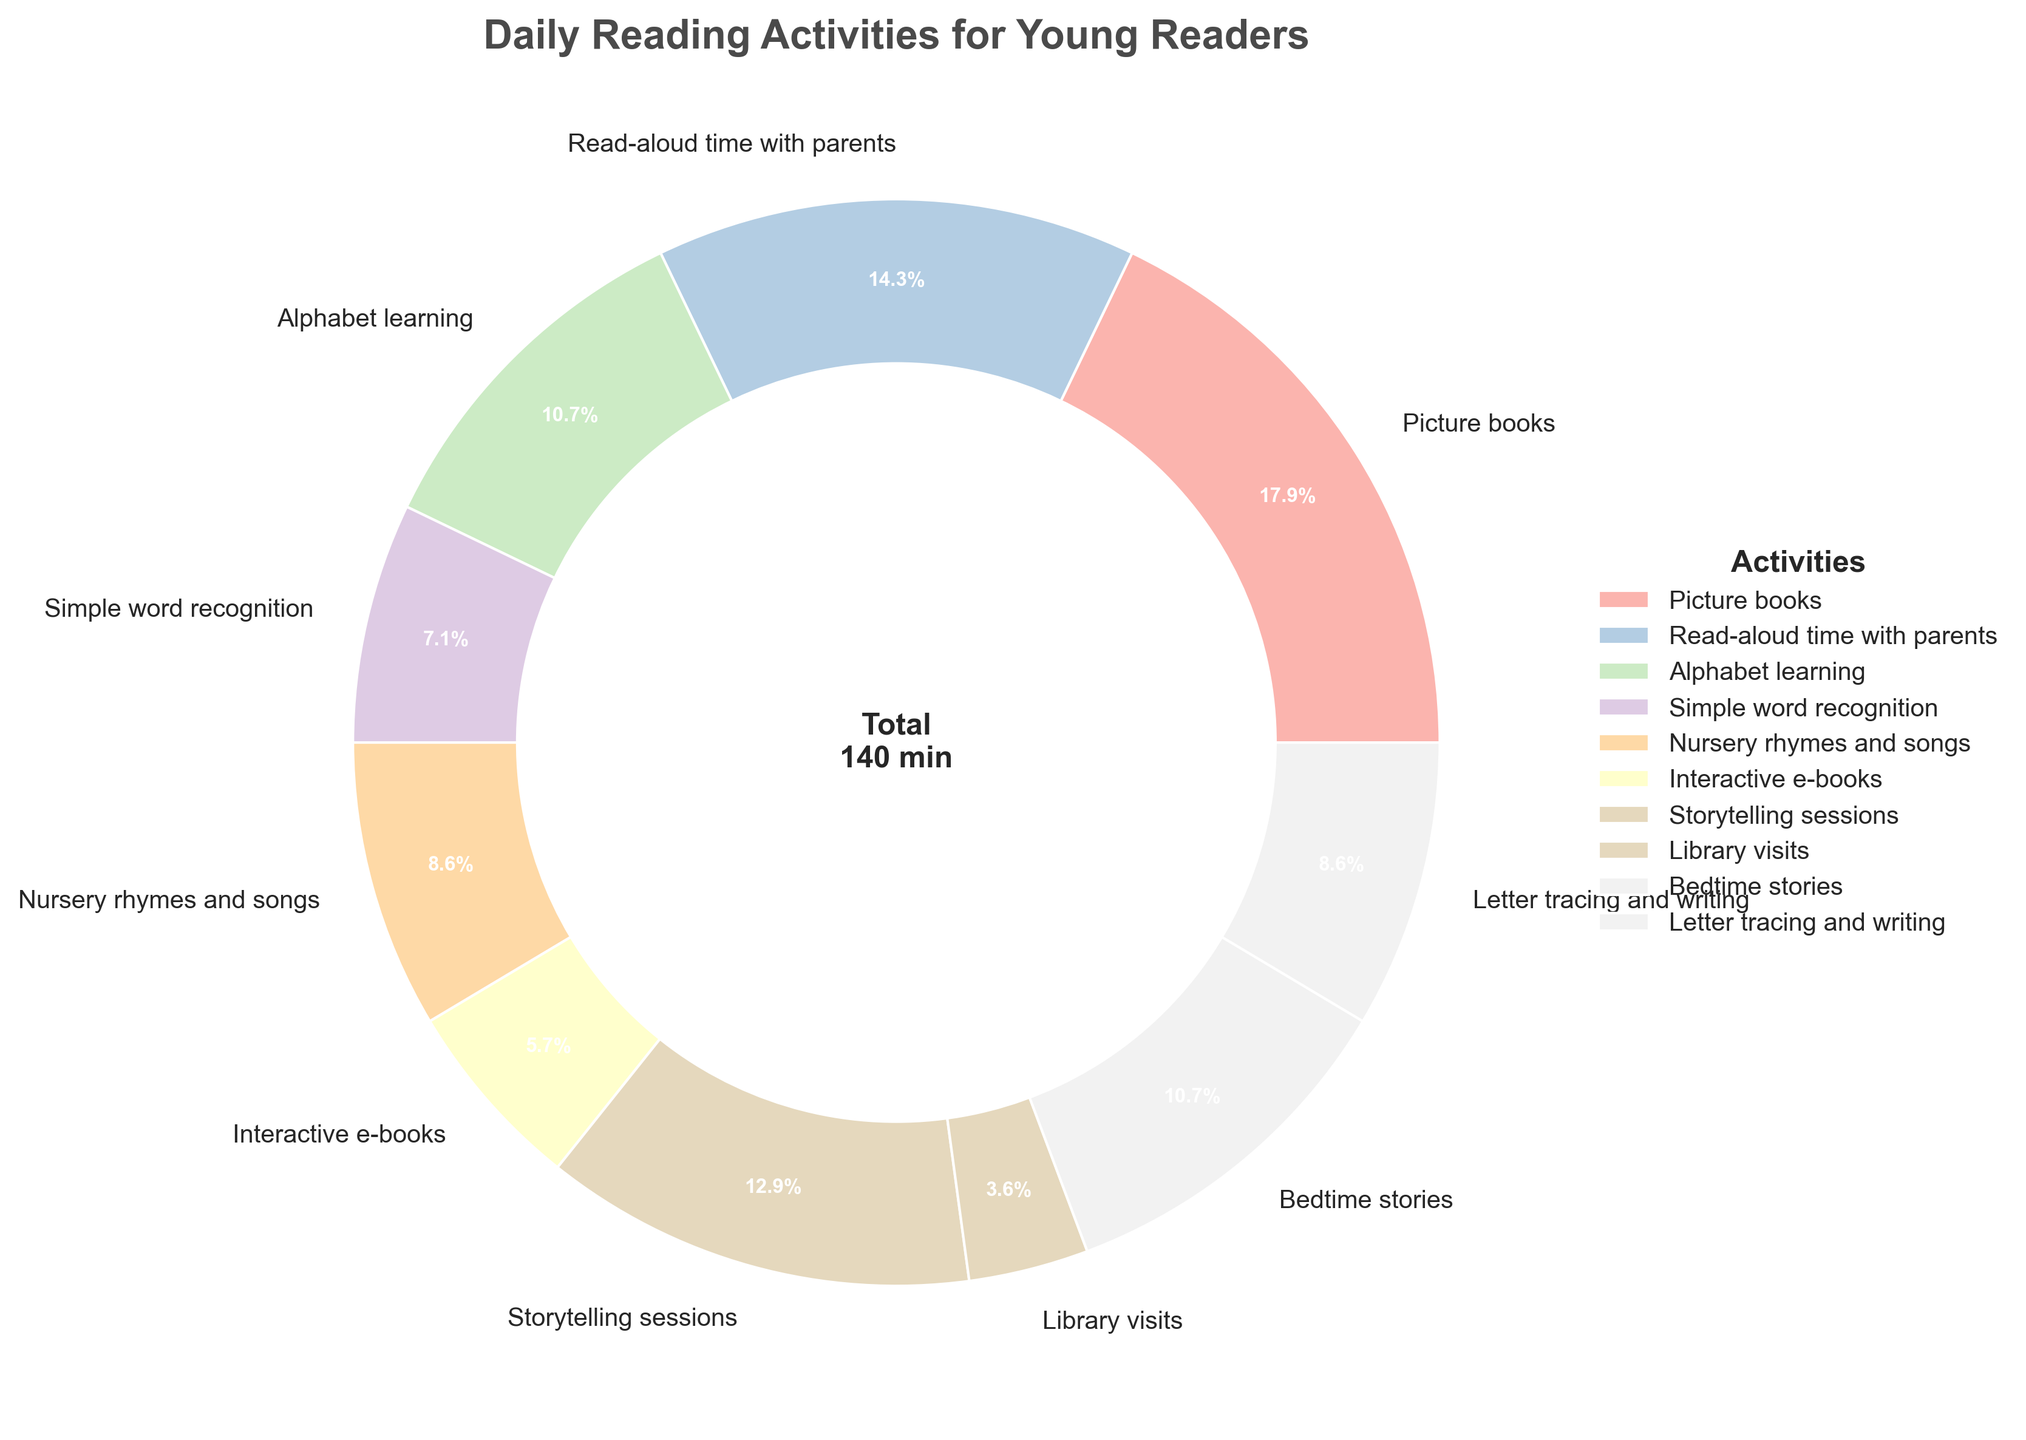What activity is spent the most time on? The activity with the largest slice on the pie chart (which is the visually largest portion) would be the one spent the most time on. Looking at the chart, the largest portion belongs to "Picture books."
Answer: Picture books How many minutes are spent on activities related to learning letters (Alphabet learning and Letter tracing and writing)? Add the minutes spent on "Alphabet learning" and "Letter tracing and writing." From the chart, Alphabet learning is 15 minutes, and Letter tracing and writing is 12 minutes. Adding these together, 15 + 12 = 27 minutes.
Answer: 27 minutes Which activity has a larger portion of time spent, Storytelling sessions or Bedtime stories? Compare the two slices of "Storytelling sessions" and "Bedtime stories" on the pie chart. The portion for "Storytelling sessions" looks larger than "Bedtime stories."
Answer: Storytelling sessions What is the total time spent on Read-aloud time with parents and Bedtime stories? Sum the minutes for "Read-aloud time with parents" and "Bedtime stories." Read-aloud time with parents is 20 minutes, and Bedtime stories are 15 minutes. Adding these together, 20 + 15 = 35 minutes.
Answer: 35 minutes Which activity spends the least amount of time, and how many minutes is it? The activity with the smallest slice on the pie chart represents the one with the least amount of time. "Library visits" has the smallest portion. The number of minutes spent is 5, as shown on the chart.
Answer: Library visits, 5 minutes Is more time spent on Nursery rhymes and songs or Interactive e-books? Compare the respective slices on the pie chart for "Nursery rhymes and songs" and "Interactive e-books." The portion for "Nursery rhymes and songs" is larger than that of "Interactive e-books."
Answer: Nursery rhymes and songs What percentage of the total time is spent on Picture books? The pie chart provides percentage information on the slices, and the "Picture books" slice shows 25%, which is the largest slice.
Answer: 25% How many more minutes are spent on Alphabet learning than Simple word recognition? Subtract the minutes spent on "Simple word recognition" from the minutes spent on "Alphabet learning." Alphabet learning is 15 minutes, and Simple word recognition is 10 minutes. The difference is 15 - 10 = 5 minutes.
Answer: 5 minutes 